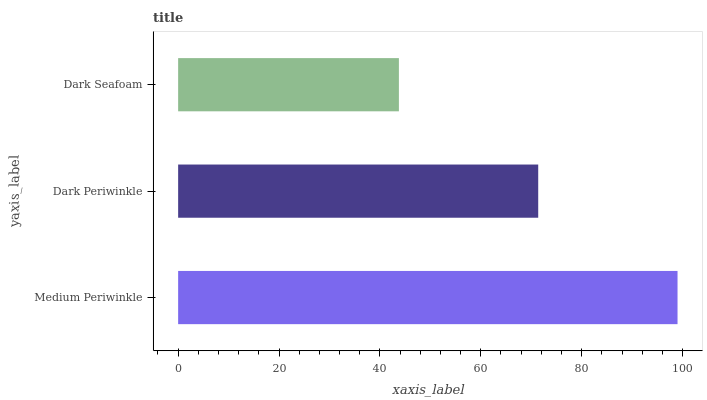Is Dark Seafoam the minimum?
Answer yes or no. Yes. Is Medium Periwinkle the maximum?
Answer yes or no. Yes. Is Dark Periwinkle the minimum?
Answer yes or no. No. Is Dark Periwinkle the maximum?
Answer yes or no. No. Is Medium Periwinkle greater than Dark Periwinkle?
Answer yes or no. Yes. Is Dark Periwinkle less than Medium Periwinkle?
Answer yes or no. Yes. Is Dark Periwinkle greater than Medium Periwinkle?
Answer yes or no. No. Is Medium Periwinkle less than Dark Periwinkle?
Answer yes or no. No. Is Dark Periwinkle the high median?
Answer yes or no. Yes. Is Dark Periwinkle the low median?
Answer yes or no. Yes. Is Dark Seafoam the high median?
Answer yes or no. No. Is Medium Periwinkle the low median?
Answer yes or no. No. 